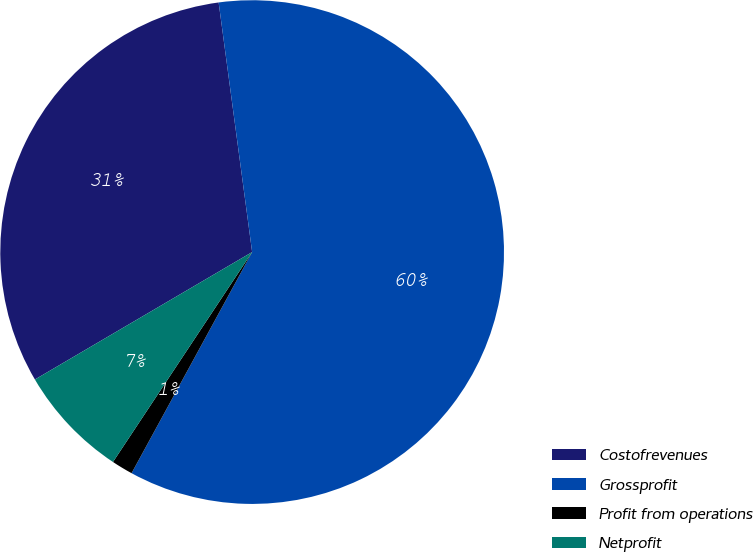Convert chart to OTSL. <chart><loc_0><loc_0><loc_500><loc_500><pie_chart><fcel>Costofrevenues<fcel>Grossprofit<fcel>Profit from operations<fcel>Netprofit<nl><fcel>31.32%<fcel>60.07%<fcel>1.37%<fcel>7.24%<nl></chart> 